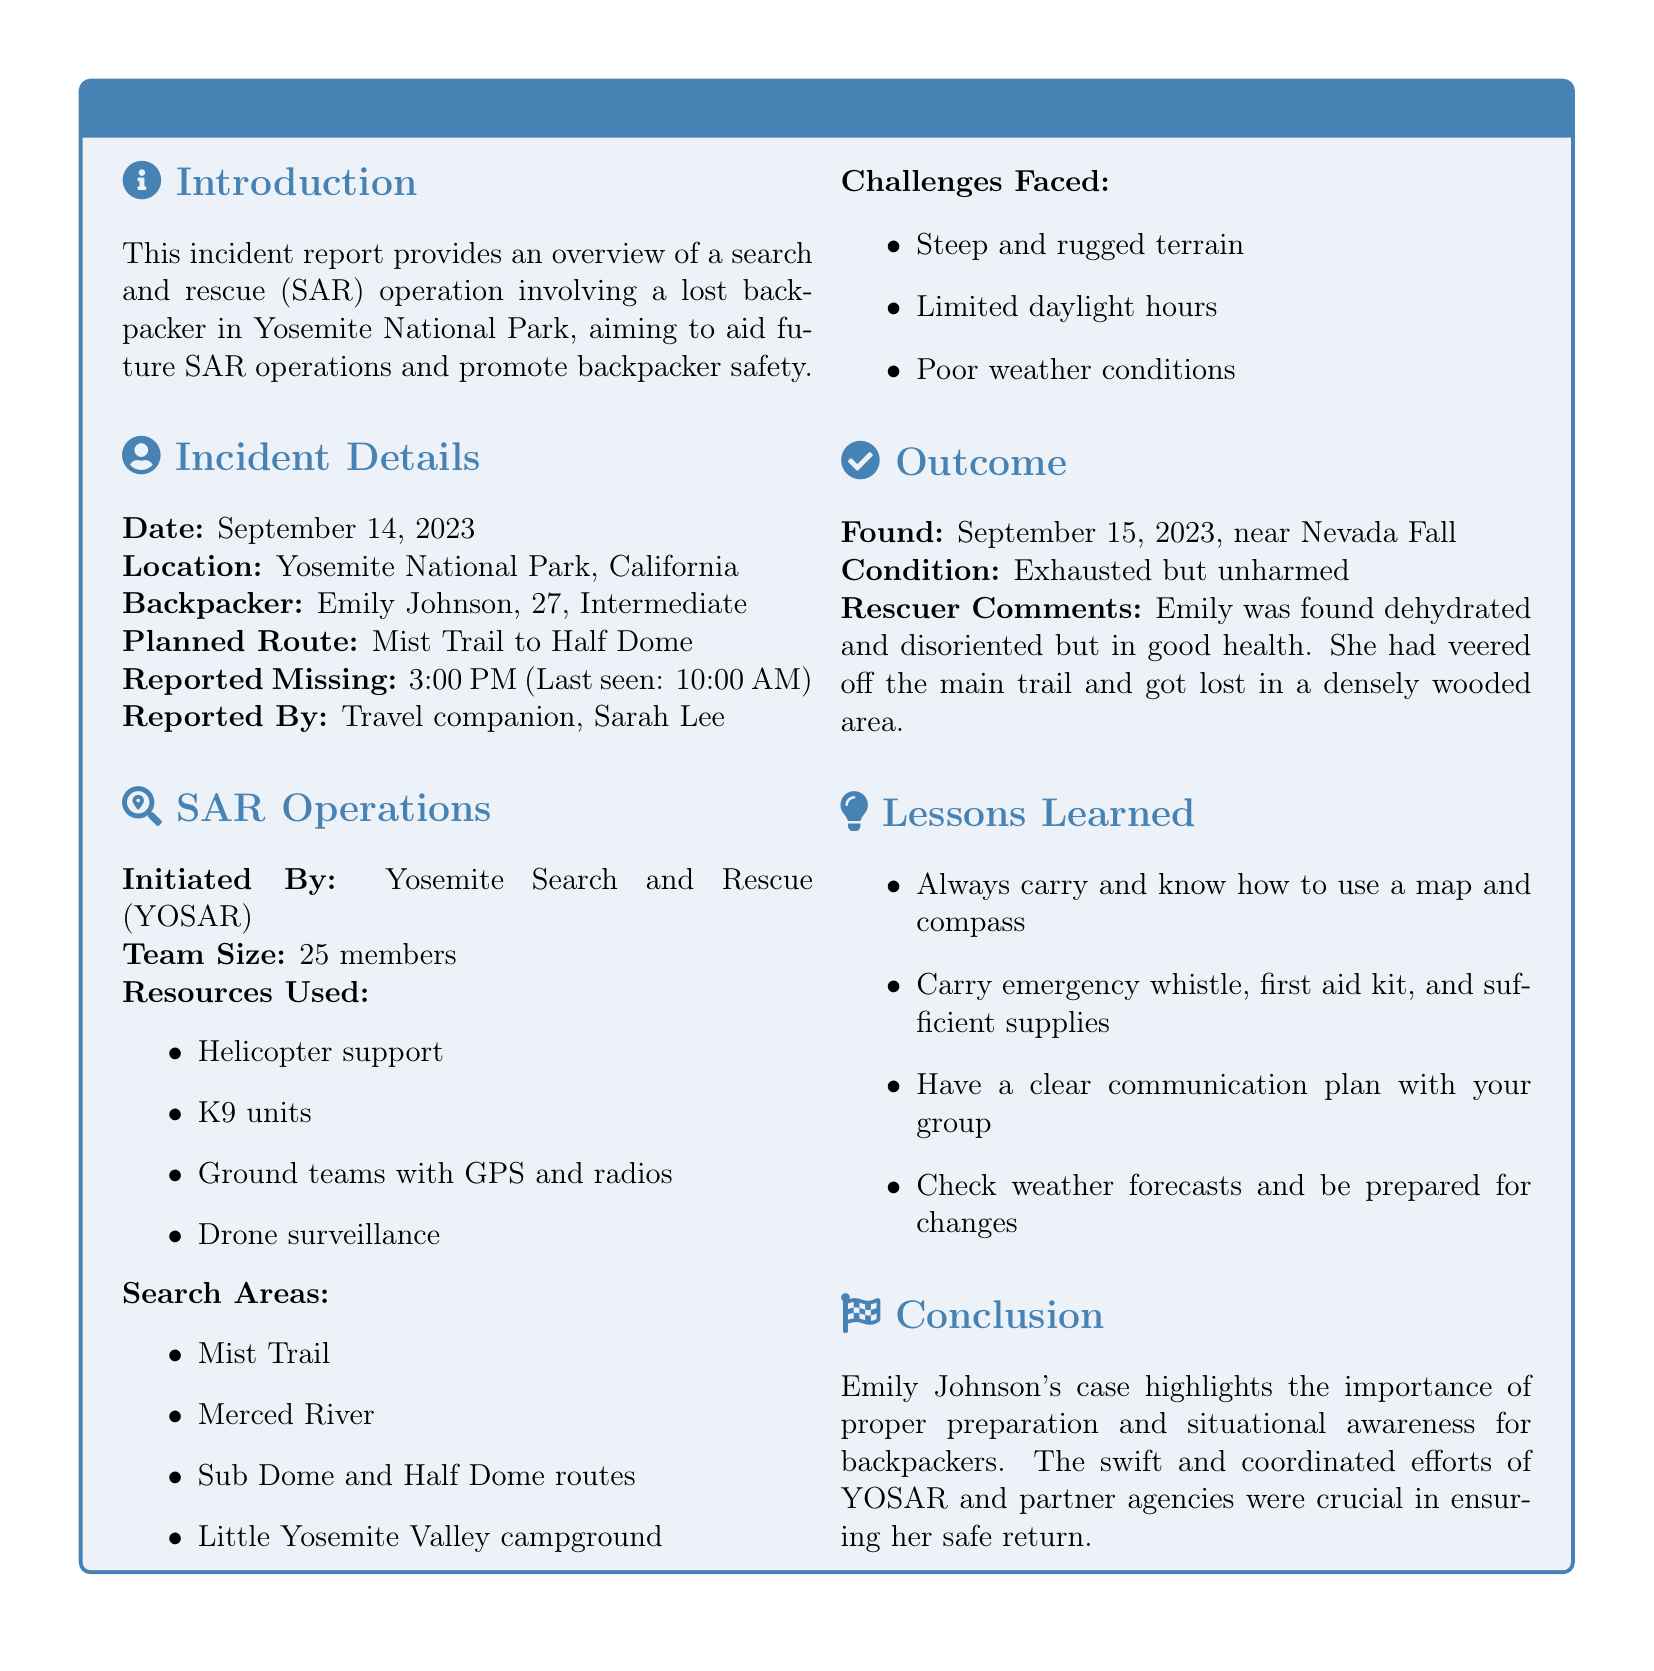What date was the backpacker reported missing? The report states that Emily Johnson was reported missing on September 14, 2023, at 3:00 PM.
Answer: September 14, 2023 Who was the travel companion that reported her missing? The document identifies Sarah Lee as the travel companion who reported Emily missing.
Answer: Sarah Lee What was Emily's condition when found? The report indicates that Emily was found exhausted but unharmed.
Answer: Exhausted but unharmed What search resources were used in the operation? The document lists resources including helicopter support, K9 units, ground teams with GPS and radios, and drone surveillance.
Answer: Helicopter support, K9 units, ground teams with GPS and radios, drone surveillance What challenges did the search team face? The report outlines challenges such as steep and rugged terrain, limited daylight hours, and poor weather conditions.
Answer: Steep and rugged terrain, limited daylight hours, poor weather conditions What was the planned route for Emily's hike? The document mentions that Emily's planned route was the Mist Trail to Half Dome.
Answer: Mist Trail to Half Dome When was Emily found? According to the report, Emily was found on September 15, 2023.
Answer: September 15, 2023 What important lesson is highlighted in the report? The report emphasizes the importance of carrying a map and compass and having a clear communication plan with the group.
Answer: Always carry and know how to use a map and compass What agency initiated the search and rescue operation? The document states that Yosemite Search and Rescue (YOSAR) initiated the operation.
Answer: Yosemite Search and Rescue (YOSAR) 